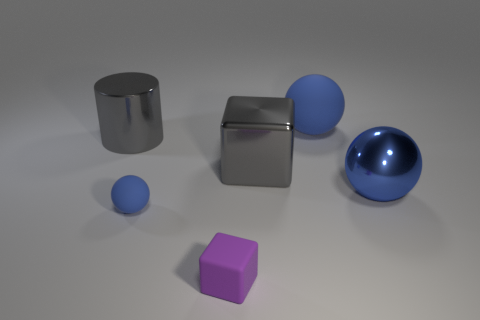How many rubber objects are either large gray blocks or small yellow cylinders?
Provide a succinct answer. 0. Is the shape of the large gray object on the right side of the rubber cube the same as the blue object that is left of the large gray block?
Offer a very short reply. No. What is the color of the thing that is to the right of the small blue ball and in front of the large blue shiny object?
Keep it short and to the point. Purple. There is a rubber sphere that is to the left of the small purple thing; does it have the same size as the gray object on the left side of the tiny purple block?
Your answer should be very brief. No. How many shiny spheres have the same color as the metallic cube?
Your response must be concise. 0. What number of small objects are either blue rubber things or green things?
Give a very brief answer. 1. Does the ball that is in front of the big blue metallic object have the same material as the gray block?
Keep it short and to the point. No. The ball in front of the blue shiny object is what color?
Offer a terse response. Blue. Are there any rubber spheres that have the same size as the gray metal block?
Provide a short and direct response. Yes. What material is the gray thing that is the same size as the metal cylinder?
Keep it short and to the point. Metal. 